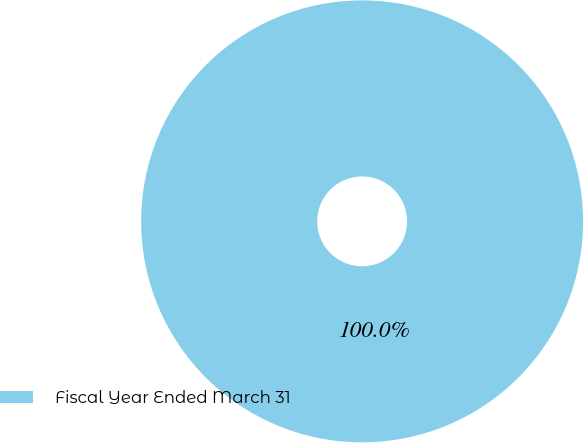Convert chart. <chart><loc_0><loc_0><loc_500><loc_500><pie_chart><fcel>Fiscal Year Ended March 31<nl><fcel>100.0%<nl></chart> 